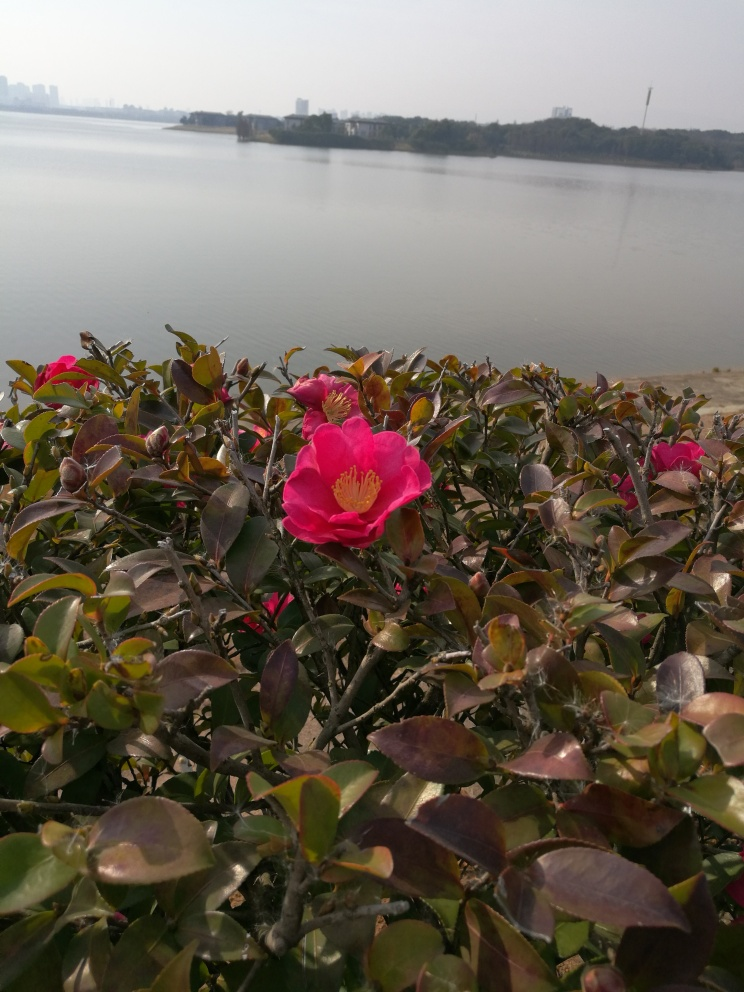Can you describe the mood or atmosphere that this image conveys? The image conveys a tranquil and serene mood. The presence of the water body in the background suggests an expansive outdoor setting which, combined with the focus on the blooms in the foreground, creates a feeling of peaceful solitude. The gentle interplay of natural elements, like flora and water, invokes a sense of quiet contemplation and a connection to nature. 